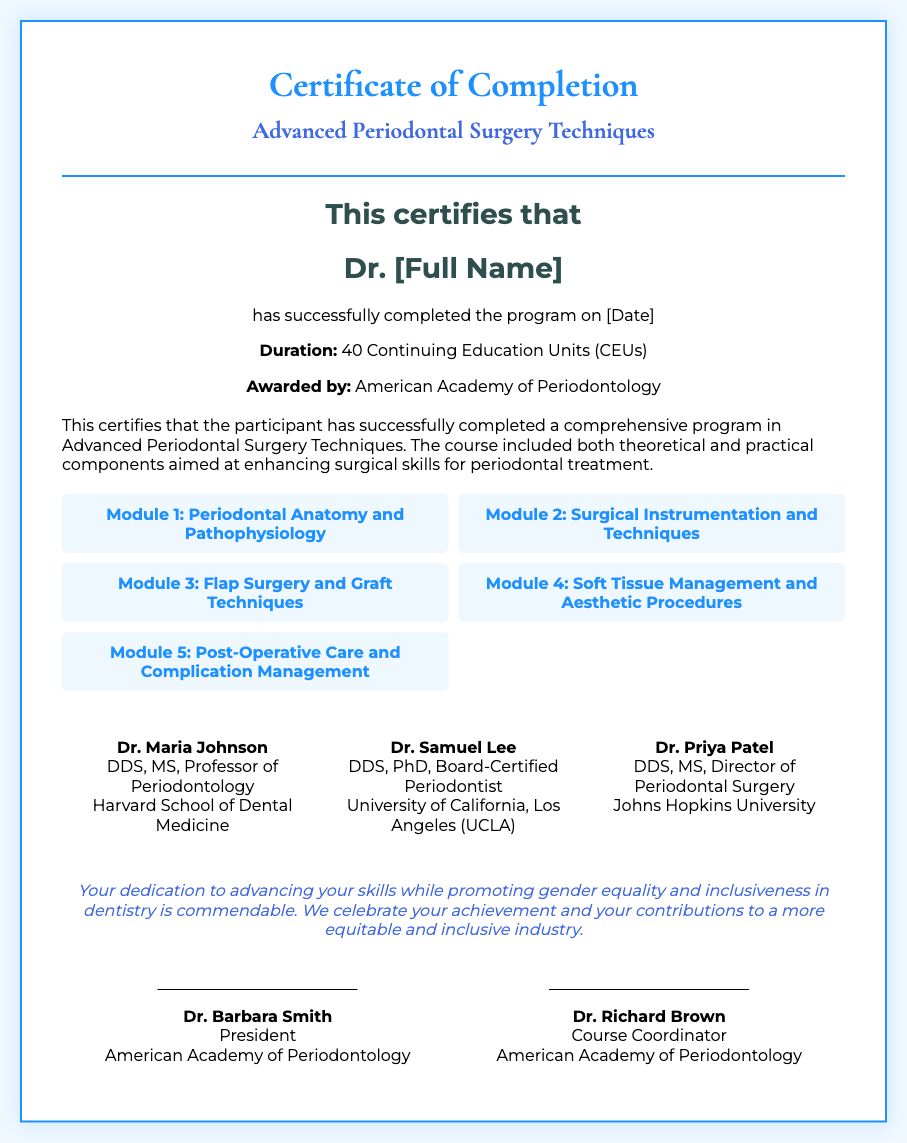What is the title of the certificate? The title is the main heading displayed at the top of the certificate document.
Answer: Certificate of Completion - Advanced Periodontal Surgery Techniques Who awarded the certificate? The awarding body is mentioned towards the end of the document.
Answer: American Academy of Periodontology What is the duration of the program? The duration is presented in terms of Continuing Education Units (CEUs) in the document.
Answer: 40 Continuing Education Units (CEUs) Name one of the modules in the course. The modules are listed in a grid and describe topics covered in the program.
Answer: Periodontal Anatomy and Pathophysiology Who is the course coordinator? The course coordinator's name is located in the signatures section at the bottom of the certificate.
Answer: Dr. Richard Brown What is the date the program was completed? The date is mentioned next to the statement regarding successful completion of the program.
Answer: [Date] How many instructors are mentioned in the document? The number of instructors is visible in the section that lists their names and titles.
Answer: 3 What is the message highlighted in the certificate? The message pertains to the participant's commitment and contributions to equality in dentistry.
Answer: Your dedication to advancing your skills while promoting gender equality and inclusiveness in dentistry is commendable What is one of the instructor's names? The names of instructors are provided in a dedicated section, each with their qualifications and affiliations.
Answer: Dr. Maria Johnson 